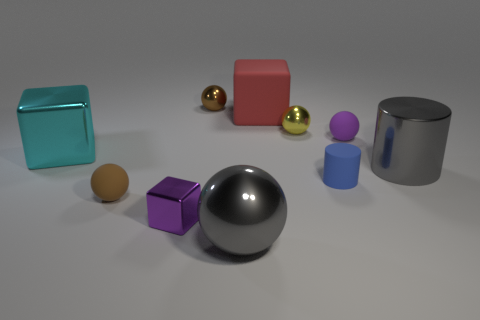Are there any tiny yellow spheres?
Ensure brevity in your answer.  Yes. Is the material of the brown thing that is to the right of the brown rubber ball the same as the gray cylinder?
Your answer should be compact. Yes. There is a metal cylinder that is the same color as the large sphere; what size is it?
Keep it short and to the point. Large. How many other cyan objects have the same size as the cyan metal object?
Your answer should be very brief. 0. Are there an equal number of small brown things that are behind the large cyan thing and cyan metallic blocks?
Offer a very short reply. Yes. How many spheres are behind the rubber block and on the left side of the tiny purple shiny cube?
Provide a short and direct response. 0. What size is the purple sphere that is the same material as the red object?
Your answer should be very brief. Small. How many big rubber objects have the same shape as the small yellow object?
Your response must be concise. 0. Are there more yellow shiny objects that are to the right of the small purple rubber thing than big metal balls?
Provide a short and direct response. No. There is a matte object that is right of the red block and behind the large cyan shiny object; what is its shape?
Give a very brief answer. Sphere. 